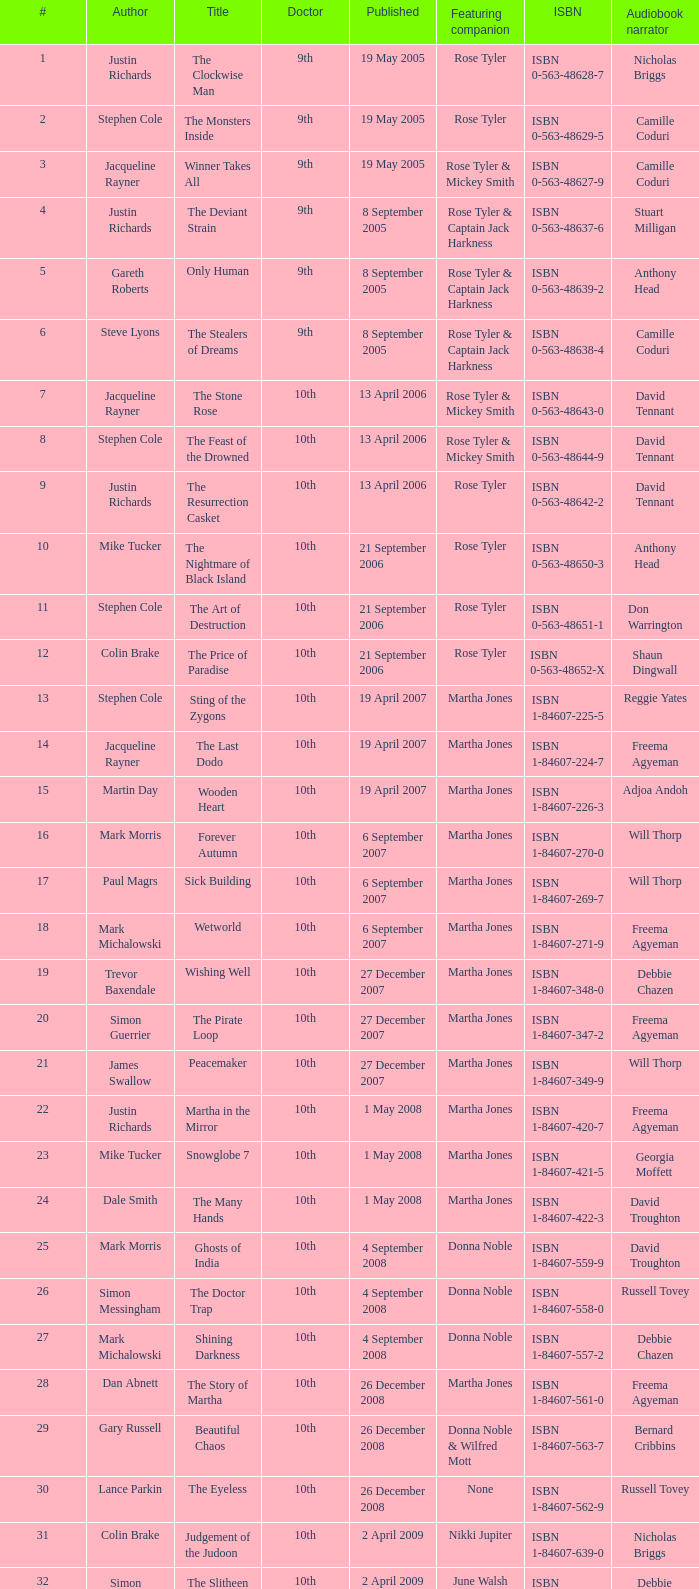What is the title of ISBN 1-84990-243-7? The Silent Stars Go By. 